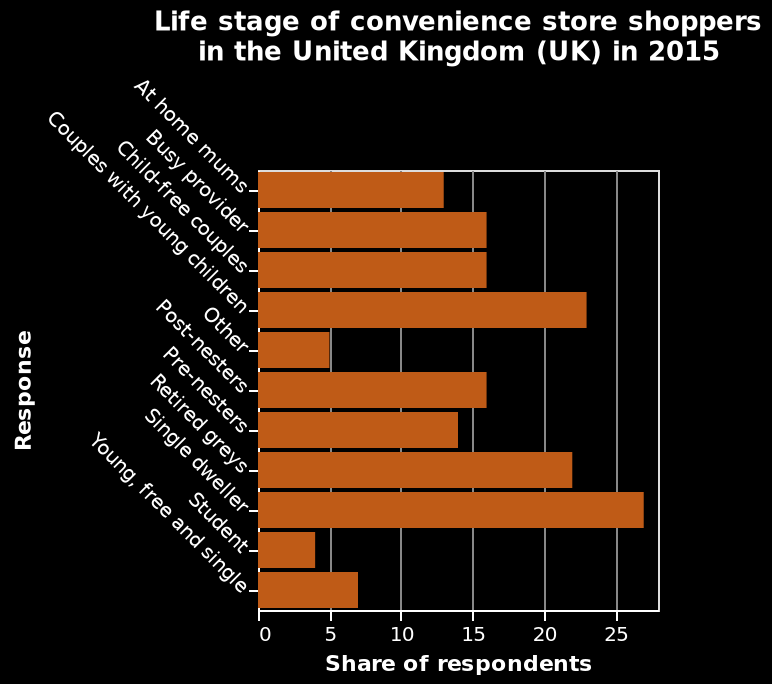<image>
please summary the statistics and relations of the chart The biggest shoppers are single dwellers. The people who shop the least are students. 